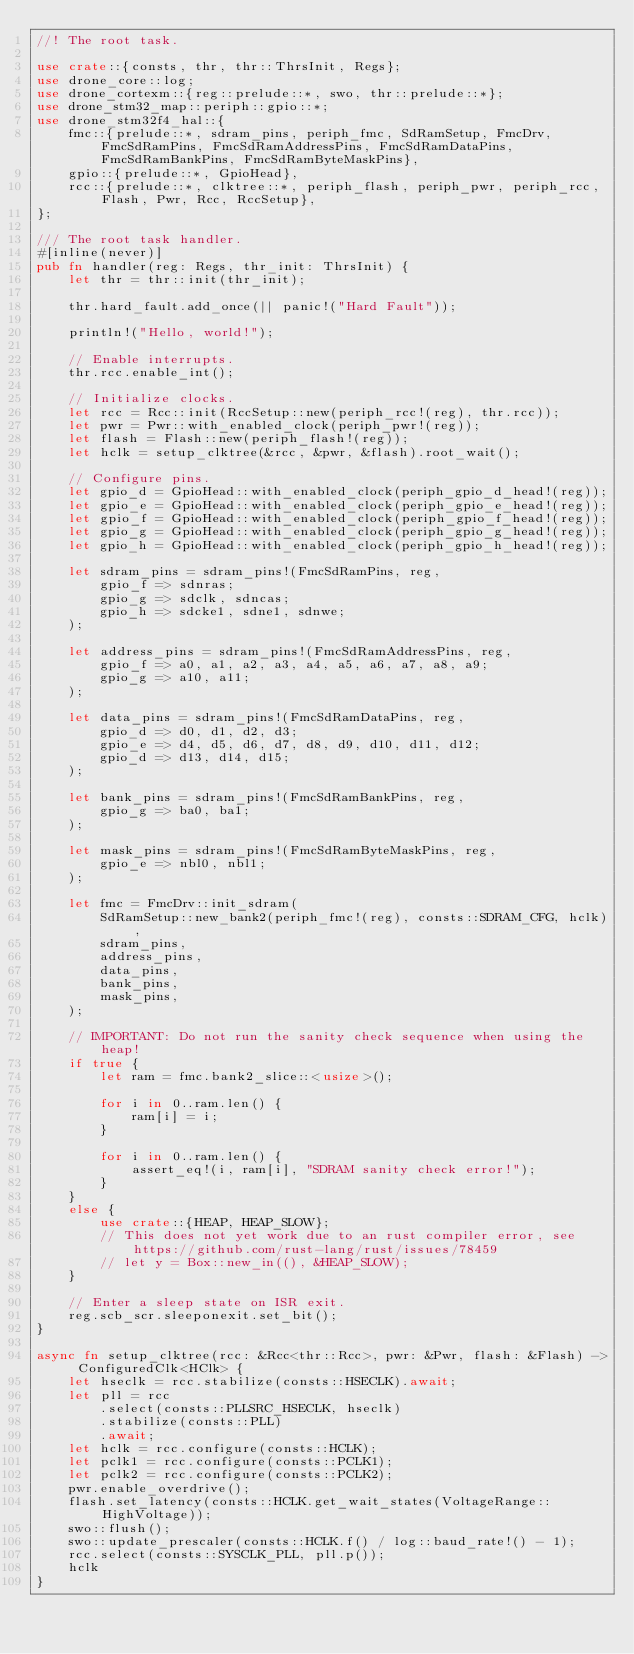Convert code to text. <code><loc_0><loc_0><loc_500><loc_500><_Rust_>//! The root task.

use crate::{consts, thr, thr::ThrsInit, Regs};
use drone_core::log;
use drone_cortexm::{reg::prelude::*, swo, thr::prelude::*};
use drone_stm32_map::periph::gpio::*;
use drone_stm32f4_hal::{
    fmc::{prelude::*, sdram_pins, periph_fmc, SdRamSetup, FmcDrv, FmcSdRamPins, FmcSdRamAddressPins, FmcSdRamDataPins, FmcSdRamBankPins, FmcSdRamByteMaskPins},
    gpio::{prelude::*, GpioHead},
    rcc::{prelude::*, clktree::*, periph_flash, periph_pwr, periph_rcc, Flash, Pwr, Rcc, RccSetup},
};

/// The root task handler.
#[inline(never)]
pub fn handler(reg: Regs, thr_init: ThrsInit) {
    let thr = thr::init(thr_init);

    thr.hard_fault.add_once(|| panic!("Hard Fault"));

    println!("Hello, world!");

    // Enable interrupts.
    thr.rcc.enable_int();

    // Initialize clocks.
    let rcc = Rcc::init(RccSetup::new(periph_rcc!(reg), thr.rcc));
    let pwr = Pwr::with_enabled_clock(periph_pwr!(reg));
    let flash = Flash::new(periph_flash!(reg));
    let hclk = setup_clktree(&rcc, &pwr, &flash).root_wait();

    // Configure pins.
    let gpio_d = GpioHead::with_enabled_clock(periph_gpio_d_head!(reg));
    let gpio_e = GpioHead::with_enabled_clock(periph_gpio_e_head!(reg));
    let gpio_f = GpioHead::with_enabled_clock(periph_gpio_f_head!(reg));
    let gpio_g = GpioHead::with_enabled_clock(periph_gpio_g_head!(reg));
    let gpio_h = GpioHead::with_enabled_clock(periph_gpio_h_head!(reg));

    let sdram_pins = sdram_pins!(FmcSdRamPins, reg,
        gpio_f => sdnras;
        gpio_g => sdclk, sdncas;
        gpio_h => sdcke1, sdne1, sdnwe;
    );

    let address_pins = sdram_pins!(FmcSdRamAddressPins, reg,
        gpio_f => a0, a1, a2, a3, a4, a5, a6, a7, a8, a9;
        gpio_g => a10, a11;
    );

    let data_pins = sdram_pins!(FmcSdRamDataPins, reg,
        gpio_d => d0, d1, d2, d3;
        gpio_e => d4, d5, d6, d7, d8, d9, d10, d11, d12;
        gpio_d => d13, d14, d15;
    );

    let bank_pins = sdram_pins!(FmcSdRamBankPins, reg,
        gpio_g => ba0, ba1;
    );

    let mask_pins = sdram_pins!(FmcSdRamByteMaskPins, reg,
        gpio_e => nbl0, nbl1;
    );

    let fmc = FmcDrv::init_sdram(
        SdRamSetup::new_bank2(periph_fmc!(reg), consts::SDRAM_CFG, hclk),
        sdram_pins,
        address_pins,
        data_pins,
        bank_pins,
        mask_pins,
    );

    // IMPORTANT: Do not run the sanity check sequence when using the heap!
    if true {
        let ram = fmc.bank2_slice::<usize>();

        for i in 0..ram.len() {
            ram[i] = i;
        }

        for i in 0..ram.len() {
            assert_eq!(i, ram[i], "SDRAM sanity check error!");
        }
    }
    else {
        use crate::{HEAP, HEAP_SLOW};
        // This does not yet work due to an rust compiler error, see https://github.com/rust-lang/rust/issues/78459
        // let y = Box::new_in((), &HEAP_SLOW);
    }

    // Enter a sleep state on ISR exit.
    reg.scb_scr.sleeponexit.set_bit();
}

async fn setup_clktree(rcc: &Rcc<thr::Rcc>, pwr: &Pwr, flash: &Flash) -> ConfiguredClk<HClk> {
    let hseclk = rcc.stabilize(consts::HSECLK).await;
    let pll = rcc
        .select(consts::PLLSRC_HSECLK, hseclk)
        .stabilize(consts::PLL)
        .await;
    let hclk = rcc.configure(consts::HCLK);
    let pclk1 = rcc.configure(consts::PCLK1);
    let pclk2 = rcc.configure(consts::PCLK2);
    pwr.enable_overdrive();
    flash.set_latency(consts::HCLK.get_wait_states(VoltageRange::HighVoltage));
    swo::flush();
    swo::update_prescaler(consts::HCLK.f() / log::baud_rate!() - 1);
    rcc.select(consts::SYSCLK_PLL, pll.p());
    hclk
}
</code> 